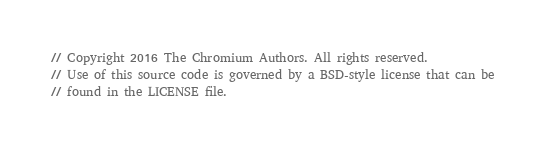<code> <loc_0><loc_0><loc_500><loc_500><_C++_>// Copyright 2016 The Chromium Authors. All rights reserved.
// Use of this source code is governed by a BSD-style license that can be
// found in the LICENSE file.
</code> 